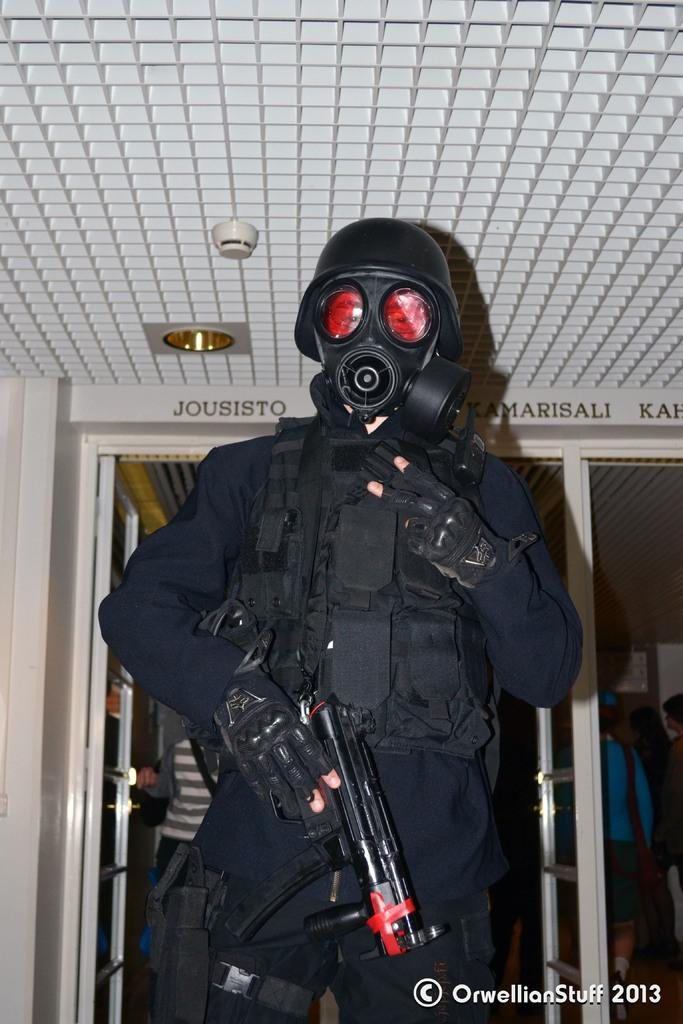What is the person in the image wearing? The person in the image is wearing a costume. What can be seen in the background of the image? There is a building in the image. How many people are visible in the image? There are people standing in the image. Can you describe any additional features of the image? There is a watermark on the image. What type of sponge is being used for the volleyball game in the image? There is no sponge or volleyball game present in the image. What topics are being discussed by the people in the image? The image does not depict a discussion or any specific topics being discussed. 